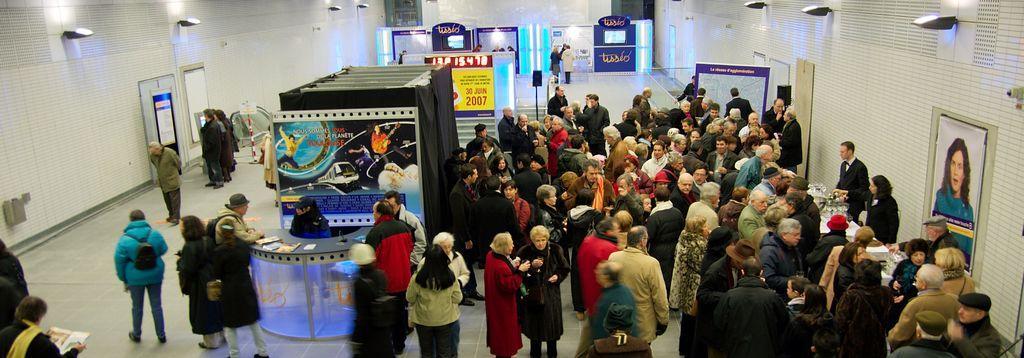Please provide a concise description of this image. In this image, we can see a group of people are standing on the floor. Few people are wearing hats and cap. Left side of the image, a person is wearing a backpack and walking. Here we can see stall, banners, black clothes, hoardings, boards, screen, wall, speakers with rods, name board, poles. 